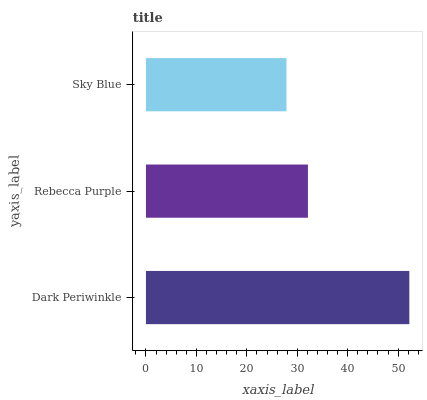Is Sky Blue the minimum?
Answer yes or no. Yes. Is Dark Periwinkle the maximum?
Answer yes or no. Yes. Is Rebecca Purple the minimum?
Answer yes or no. No. Is Rebecca Purple the maximum?
Answer yes or no. No. Is Dark Periwinkle greater than Rebecca Purple?
Answer yes or no. Yes. Is Rebecca Purple less than Dark Periwinkle?
Answer yes or no. Yes. Is Rebecca Purple greater than Dark Periwinkle?
Answer yes or no. No. Is Dark Periwinkle less than Rebecca Purple?
Answer yes or no. No. Is Rebecca Purple the high median?
Answer yes or no. Yes. Is Rebecca Purple the low median?
Answer yes or no. Yes. Is Sky Blue the high median?
Answer yes or no. No. Is Dark Periwinkle the low median?
Answer yes or no. No. 